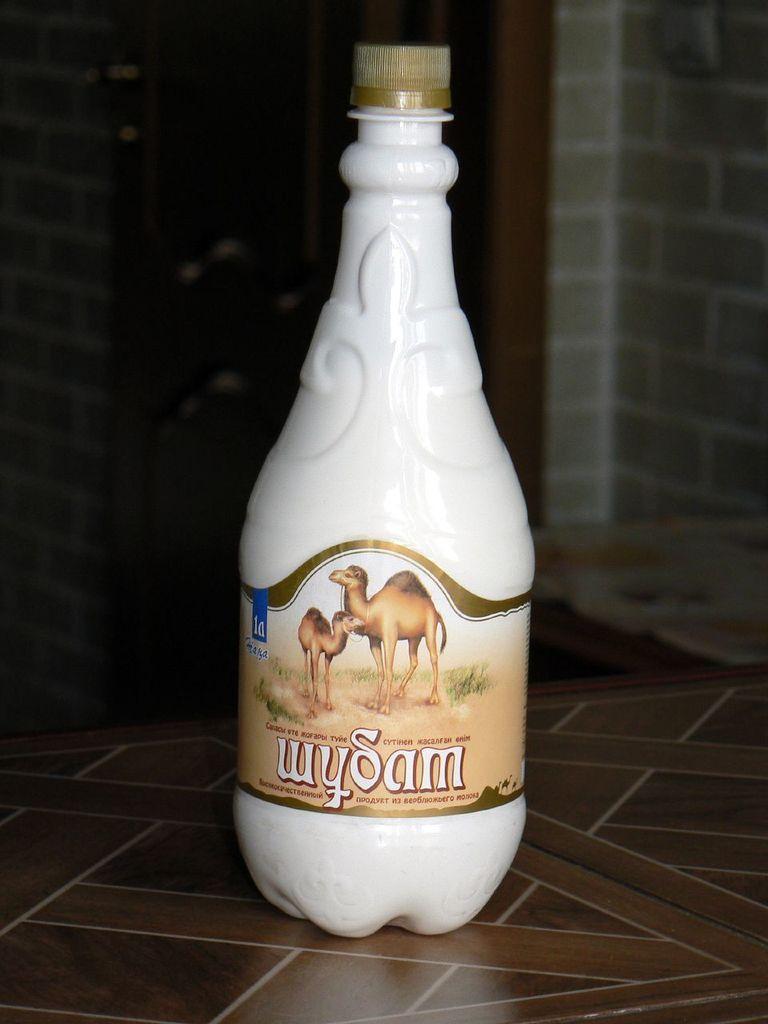In one or two sentences, can you explain what this image depicts? In this picture we can see bottle on the table. On the background we can see wall. 